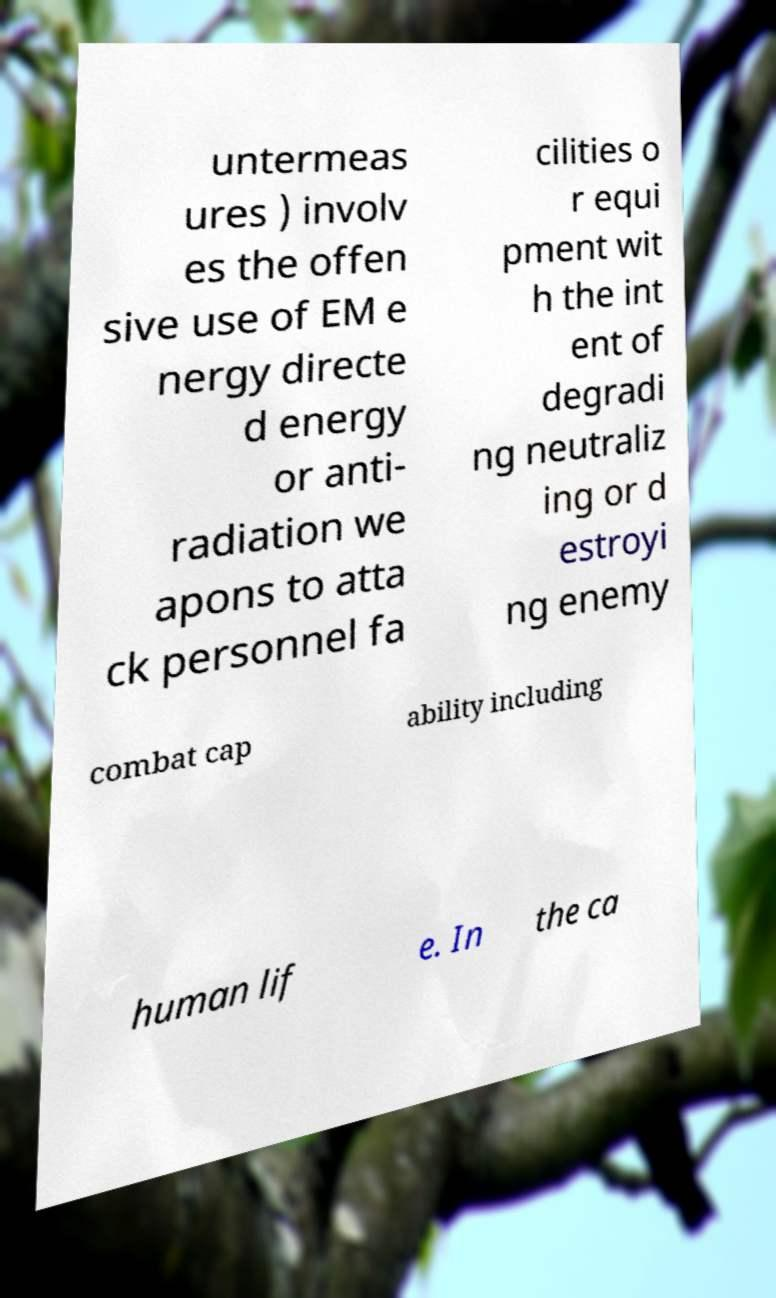What messages or text are displayed in this image? I need them in a readable, typed format. untermeas ures ) involv es the offen sive use of EM e nergy directe d energy or anti- radiation we apons to atta ck personnel fa cilities o r equi pment wit h the int ent of degradi ng neutraliz ing or d estroyi ng enemy combat cap ability including human lif e. In the ca 